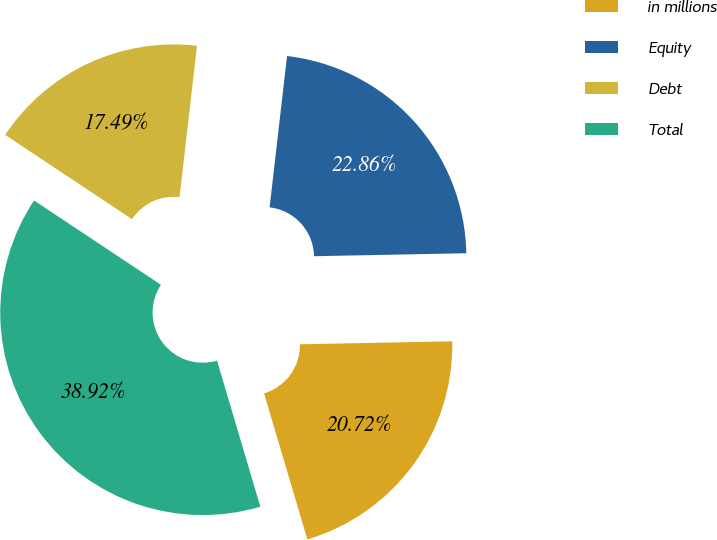<chart> <loc_0><loc_0><loc_500><loc_500><pie_chart><fcel>in millions<fcel>Equity<fcel>Debt<fcel>Total<nl><fcel>20.72%<fcel>22.86%<fcel>17.49%<fcel>38.92%<nl></chart> 